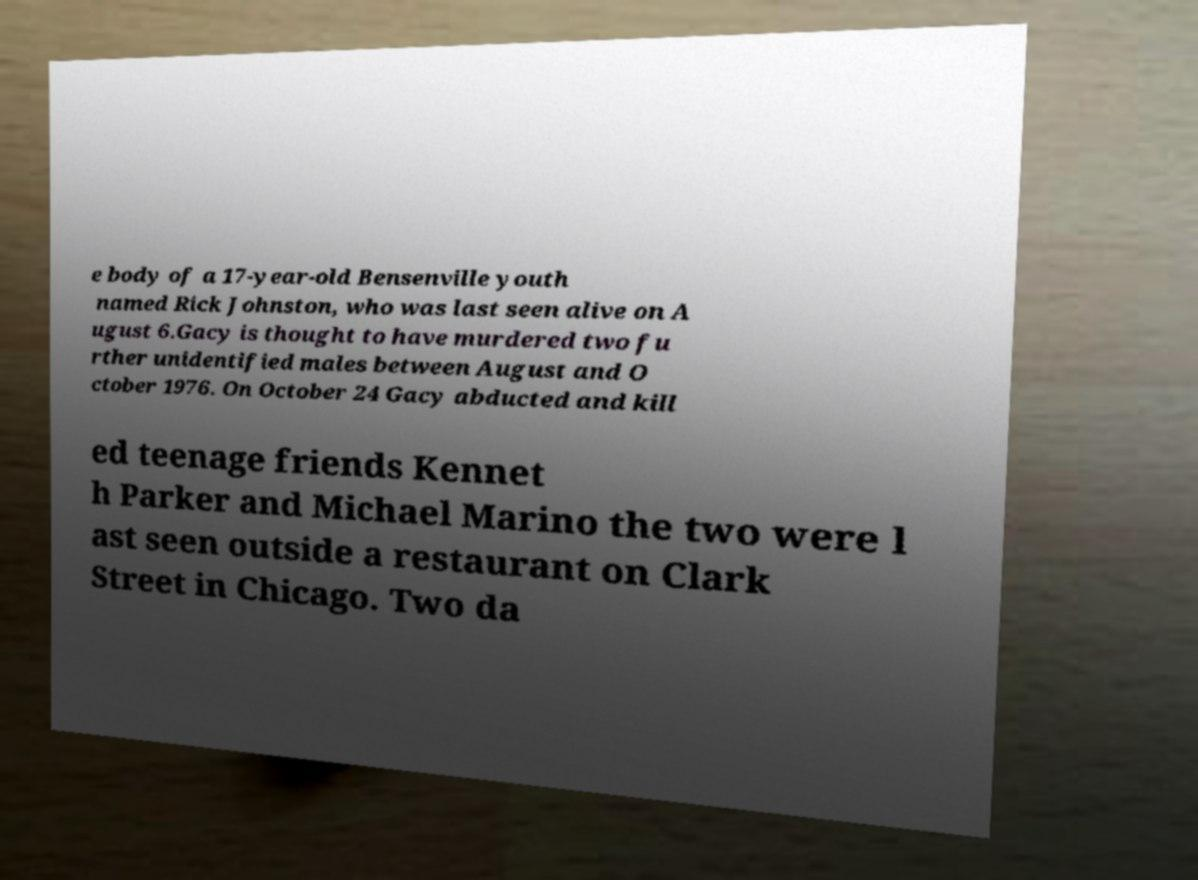Could you extract and type out the text from this image? e body of a 17-year-old Bensenville youth named Rick Johnston, who was last seen alive on A ugust 6.Gacy is thought to have murdered two fu rther unidentified males between August and O ctober 1976. On October 24 Gacy abducted and kill ed teenage friends Kennet h Parker and Michael Marino the two were l ast seen outside a restaurant on Clark Street in Chicago. Two da 